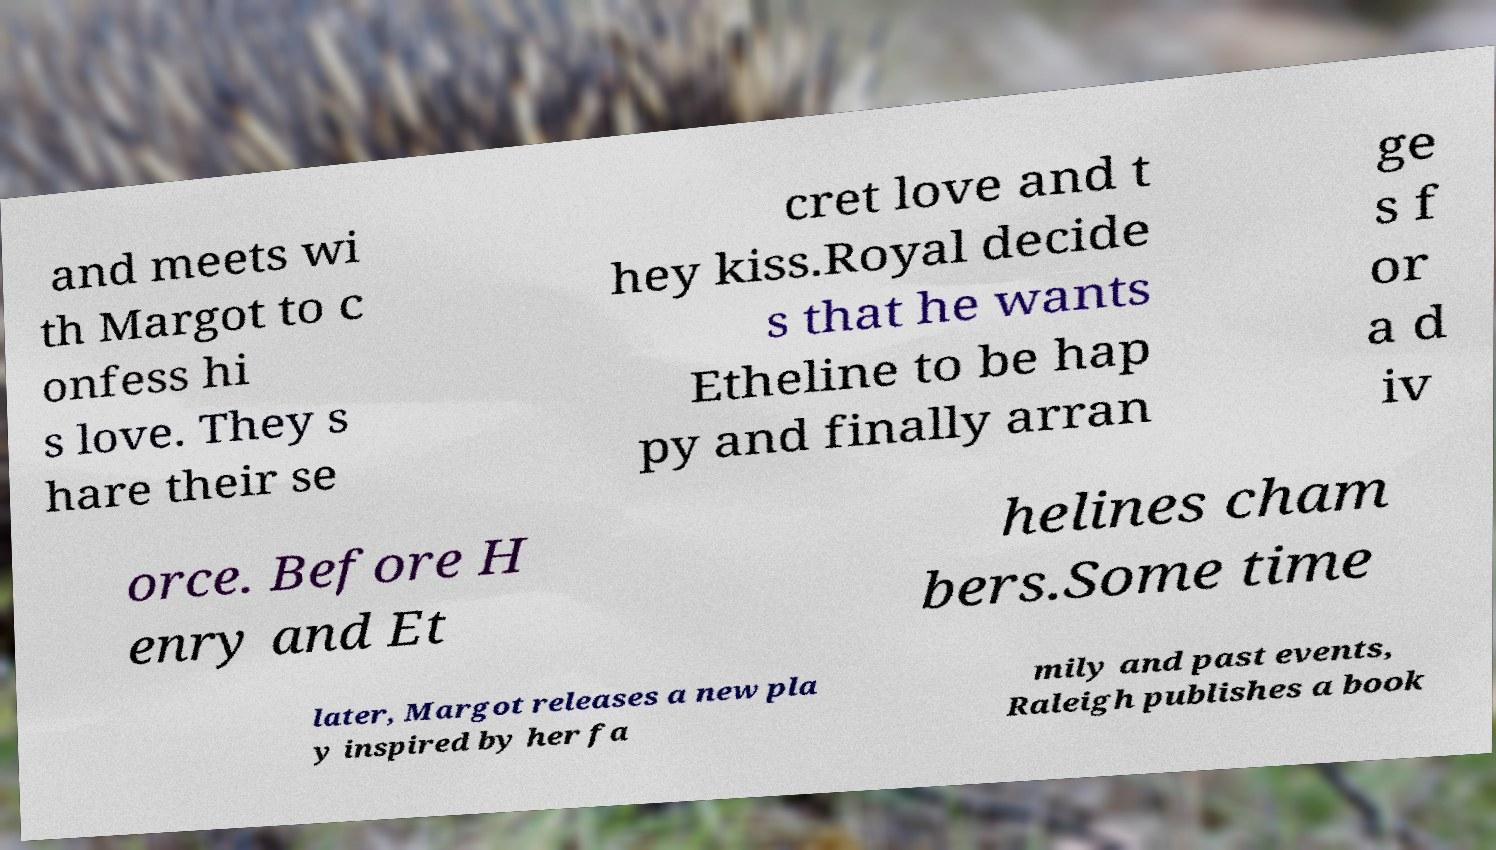Can you read and provide the text displayed in the image?This photo seems to have some interesting text. Can you extract and type it out for me? and meets wi th Margot to c onfess hi s love. They s hare their se cret love and t hey kiss.Royal decide s that he wants Etheline to be hap py and finally arran ge s f or a d iv orce. Before H enry and Et helines cham bers.Some time later, Margot releases a new pla y inspired by her fa mily and past events, Raleigh publishes a book 